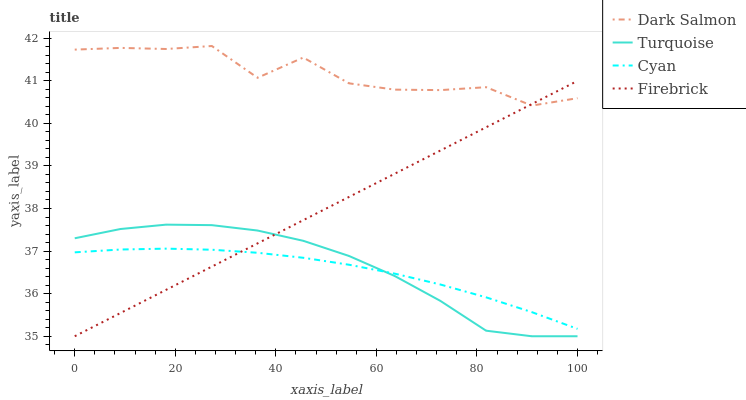Does Cyan have the minimum area under the curve?
Answer yes or no. Yes. Does Dark Salmon have the maximum area under the curve?
Answer yes or no. Yes. Does Turquoise have the minimum area under the curve?
Answer yes or no. No. Does Turquoise have the maximum area under the curve?
Answer yes or no. No. Is Firebrick the smoothest?
Answer yes or no. Yes. Is Dark Salmon the roughest?
Answer yes or no. Yes. Is Turquoise the smoothest?
Answer yes or no. No. Is Turquoise the roughest?
Answer yes or no. No. Does Turquoise have the lowest value?
Answer yes or no. Yes. Does Dark Salmon have the lowest value?
Answer yes or no. No. Does Dark Salmon have the highest value?
Answer yes or no. Yes. Does Turquoise have the highest value?
Answer yes or no. No. Is Cyan less than Dark Salmon?
Answer yes or no. Yes. Is Dark Salmon greater than Cyan?
Answer yes or no. Yes. Does Firebrick intersect Dark Salmon?
Answer yes or no. Yes. Is Firebrick less than Dark Salmon?
Answer yes or no. No. Is Firebrick greater than Dark Salmon?
Answer yes or no. No. Does Cyan intersect Dark Salmon?
Answer yes or no. No. 